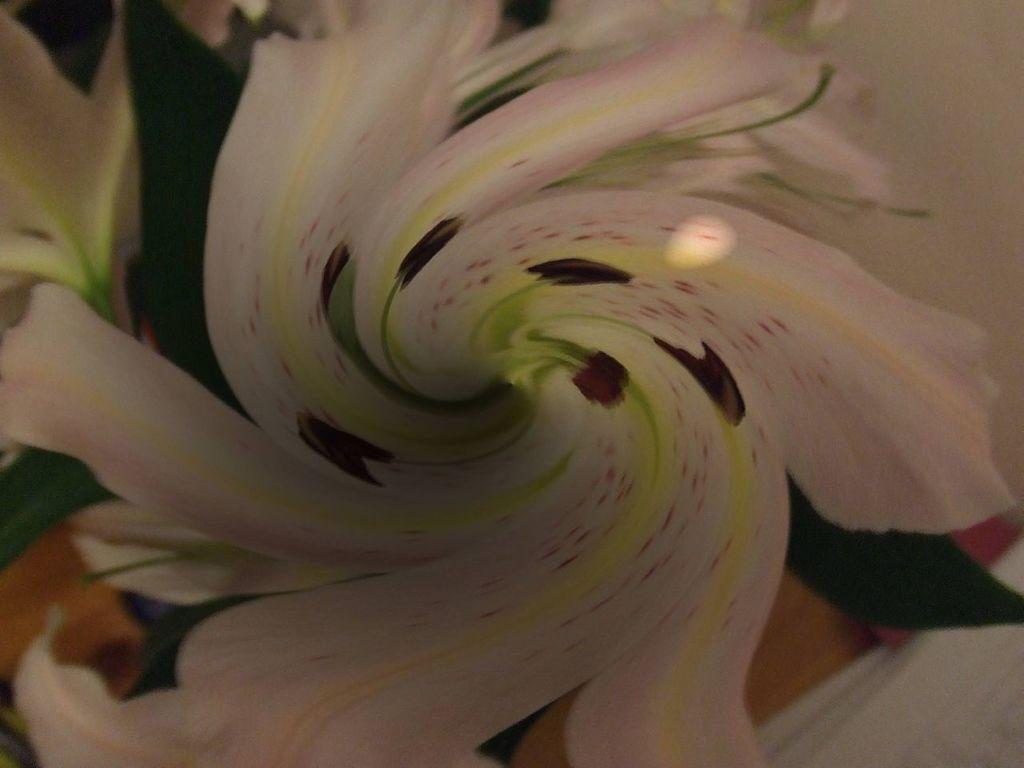What type of flower is present in the image? There is a white color flower in the image. Can you tell me what the writer is doing with the needle and map in the image? There is no writer, needle, or map present in the image; it only features a white color flower. 